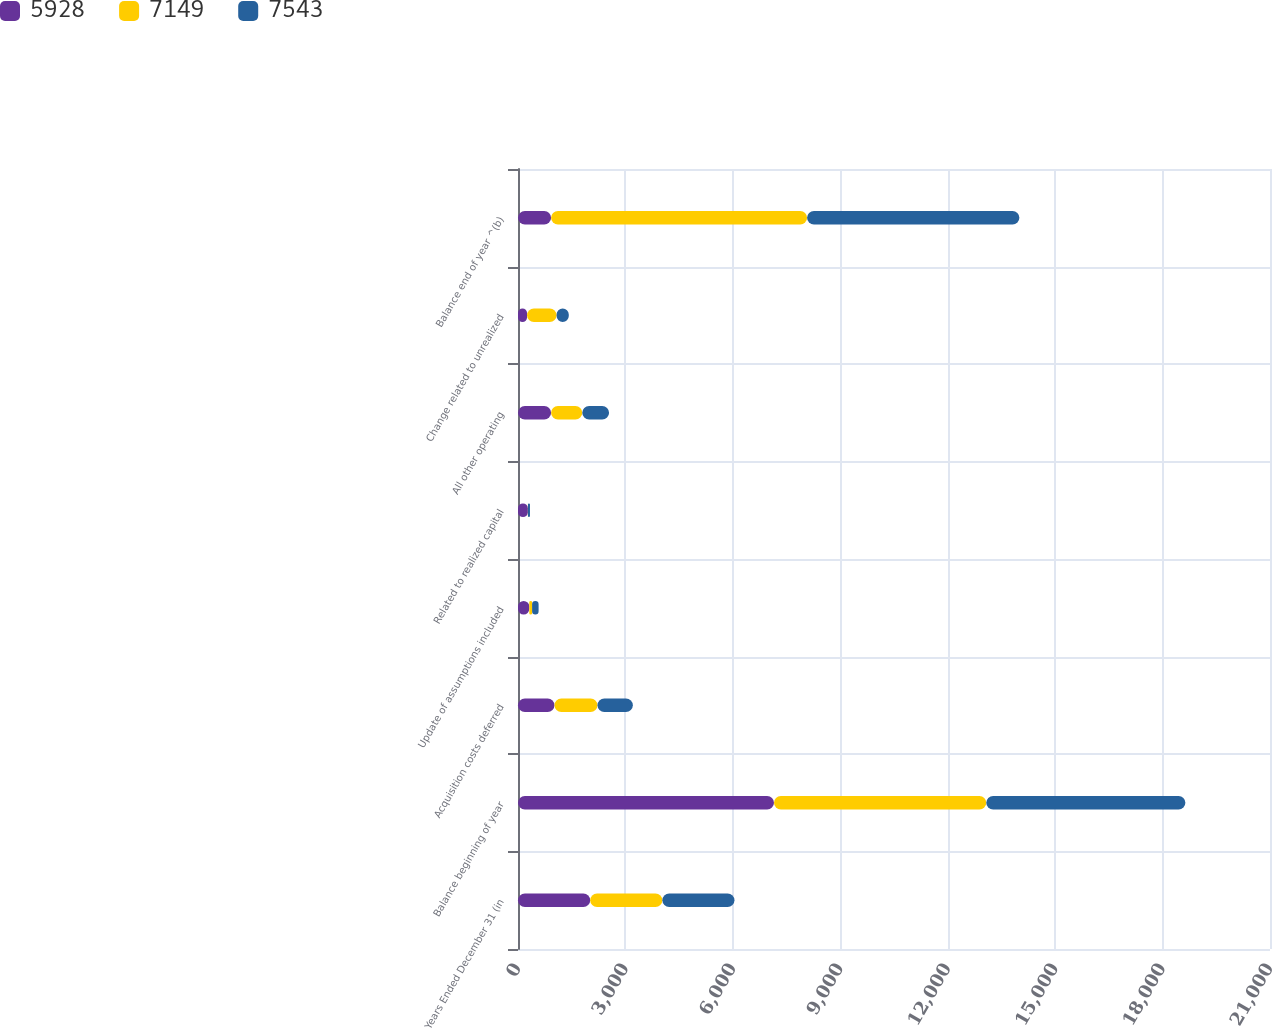Convert chart to OTSL. <chart><loc_0><loc_0><loc_500><loc_500><stacked_bar_chart><ecel><fcel>Years Ended December 31 (in<fcel>Balance beginning of year<fcel>Acquisition costs deferred<fcel>Update of assumptions included<fcel>Related to realized capital<fcel>All other operating<fcel>Change related to unrealized<fcel>Balance end of year ^(b)<nl><fcel>5928<fcel>2016<fcel>7149<fcel>1019<fcel>315<fcel>276<fcel>924<fcel>252<fcel>924<nl><fcel>7149<fcel>2015<fcel>5928<fcel>1200<fcel>79<fcel>2<fcel>871<fcel>826<fcel>7149<nl><fcel>7543<fcel>2014<fcel>5560<fcel>988<fcel>181<fcel>56<fcel>748<fcel>340<fcel>5928<nl></chart> 